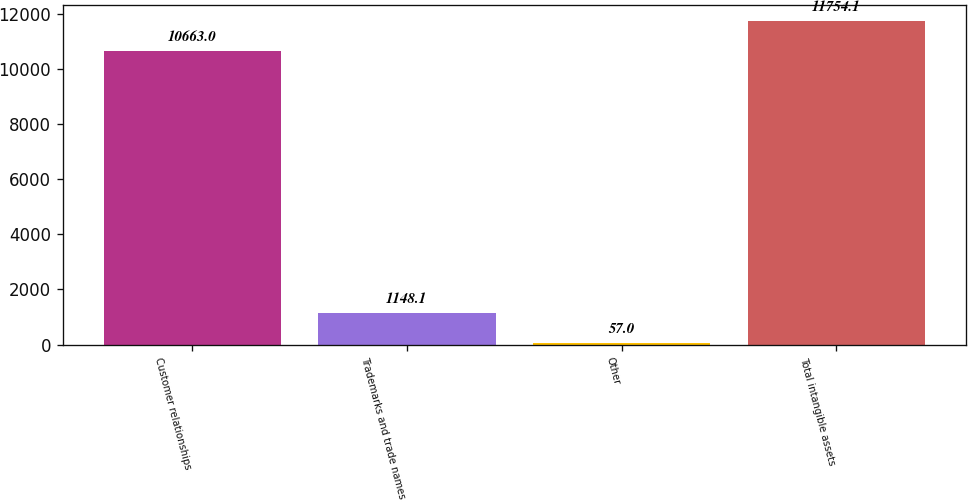<chart> <loc_0><loc_0><loc_500><loc_500><bar_chart><fcel>Customer relationships<fcel>Trademarks and trade names<fcel>Other<fcel>Total intangible assets<nl><fcel>10663<fcel>1148.1<fcel>57<fcel>11754.1<nl></chart> 